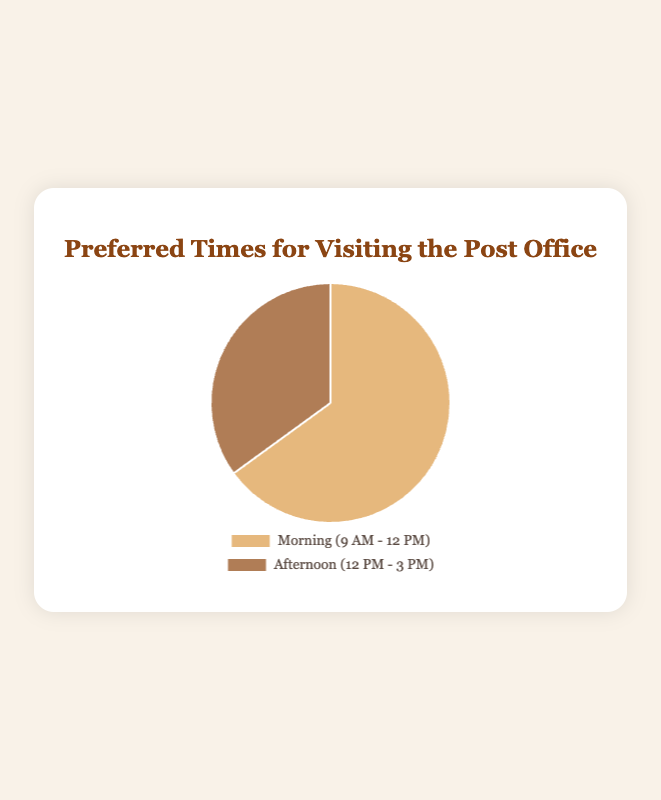What percentage of people prefer to visit the post office in the morning? The chart shows that the segment labeled "Morning (9 AM - 12 PM)" represents 65% of the total.
Answer: 65% What percentage of people prefer to visit the post office in the afternoon? The chart shows that the segment labeled "Afternoon (12 PM - 3 PM)" represents 35% of the total.
Answer: 35% Is the morning or the afternoon a more preferred time for visiting the post office? By comparing the values, the morning time (65%) is higher than the afternoon time (35%), indicating it's more preferred.
Answer: Morning How much greater is the percentage of people who prefer visiting the post office in the morning compared to the afternoon? Subtract the percentage of afternoon visitors (35%) from the percentage of morning visitors (65%). 65% - 35% = 30%.
Answer: 30% What is the percentage difference between the most preferred and the least preferred visiting times? Subtract the least preferred time percentage (35%) from the most preferred time percentage (65%). 65% - 35% = 30%.
Answer: 30% If you add the percentages of both preferred times, what total do you get? Add the morning preference (65%) to the afternoon preference (35%). 65% + 35% = 100%.
Answer: 100% Which portion of the pie chart is represented in a lighter color? Visually, the lighter color corresponds to the label "Morning (9 AM - 12 PM)."
Answer: Morning (9 AM - 12 PM) What does the darker segment of the pie chart represent? The darker segment of the pie chart is labeled "Afternoon (12 PM - 3 PM)."
Answer: Afternoon (12 PM - 3 PM) What is the ratio of people preferring to visit the post office in the morning to those preferring the afternoon? The ratio is the morning percentage (65%) to the afternoon percentage (35%). Simplify the ratio 65:35 to 13:7.
Answer: 13:7 